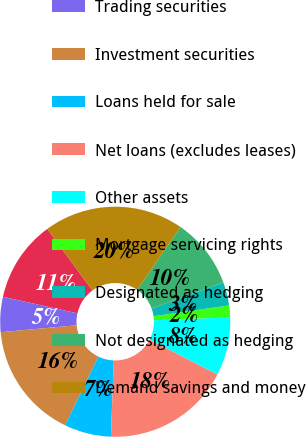<chart> <loc_0><loc_0><loc_500><loc_500><pie_chart><fcel>Cash and short-term assets<fcel>Trading securities<fcel>Investment securities<fcel>Loans held for sale<fcel>Net loans (excludes leases)<fcel>Other assets<fcel>Mortgage servicing rights<fcel>Designated as hedging<fcel>Not designated as hedging<fcel>Demand savings and money<nl><fcel>11.47%<fcel>4.93%<fcel>16.38%<fcel>6.57%<fcel>18.01%<fcel>8.2%<fcel>1.66%<fcel>3.29%<fcel>9.84%<fcel>19.65%<nl></chart> 